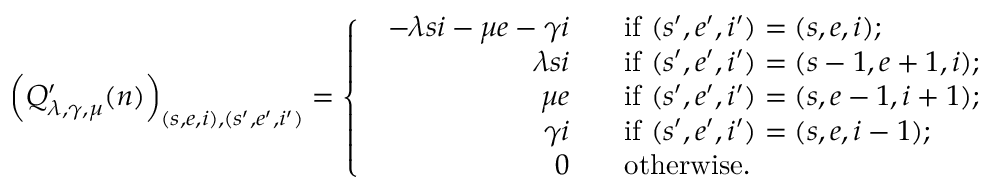<formula> <loc_0><loc_0><loc_500><loc_500>\left ( Q _ { \lambda , \gamma , \mu } ^ { \prime } ( n ) \right ) _ { ( s , e , i ) , ( s ^ { \prime } , e ^ { \prime } , i ^ { \prime } ) } = \left \{ \begin{array} { l l } { \begin{array} { r l } { - \lambda s i - \mu e - \gamma i \, } & { i f ( s ^ { \prime } , e ^ { \prime } , i ^ { \prime } ) = ( s , e , i ) ; } \\ { \lambda s i \, } & { i f ( s ^ { \prime } , e ^ { \prime } , i ^ { \prime } ) = ( s - 1 , e + 1 , i ) ; } \\ { \mu e \, } & { i f ( s ^ { \prime } , e ^ { \prime } , i ^ { \prime } ) = ( s , e - 1 , i + 1 ) ; } \\ { \gamma i \, } & { i f ( s ^ { \prime } , e ^ { \prime } , i ^ { \prime } ) = ( s , e , i - 1 ) ; } \\ { 0 \, } & { o t h e r w i s e . } \end{array} } \end{array}</formula> 